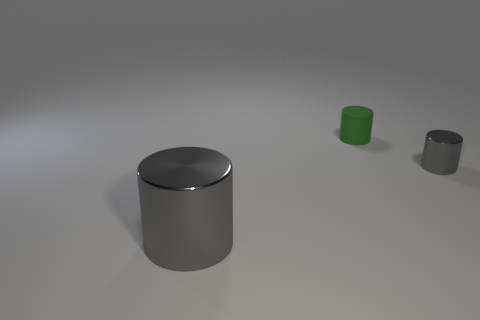Add 1 green matte things. How many objects exist? 4 Subtract 0 purple cylinders. How many objects are left? 3 Subtract all green rubber things. Subtract all green rubber things. How many objects are left? 1 Add 2 large things. How many large things are left? 3 Add 3 tiny yellow cubes. How many tiny yellow cubes exist? 3 